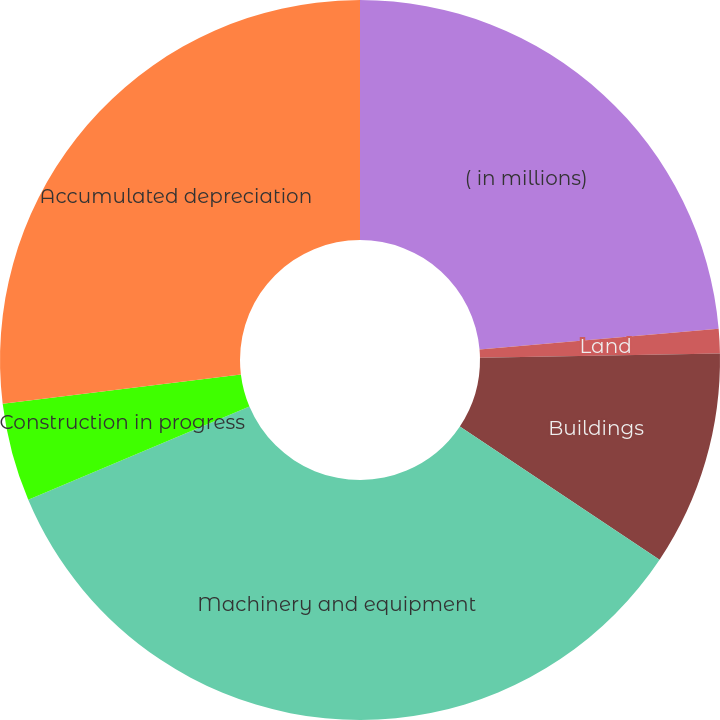Convert chart to OTSL. <chart><loc_0><loc_0><loc_500><loc_500><pie_chart><fcel>( in millions)<fcel>Land<fcel>Buildings<fcel>Machinery and equipment<fcel>Construction in progress<fcel>Accumulated depreciation<nl><fcel>23.62%<fcel>1.09%<fcel>9.65%<fcel>34.3%<fcel>4.41%<fcel>26.94%<nl></chart> 